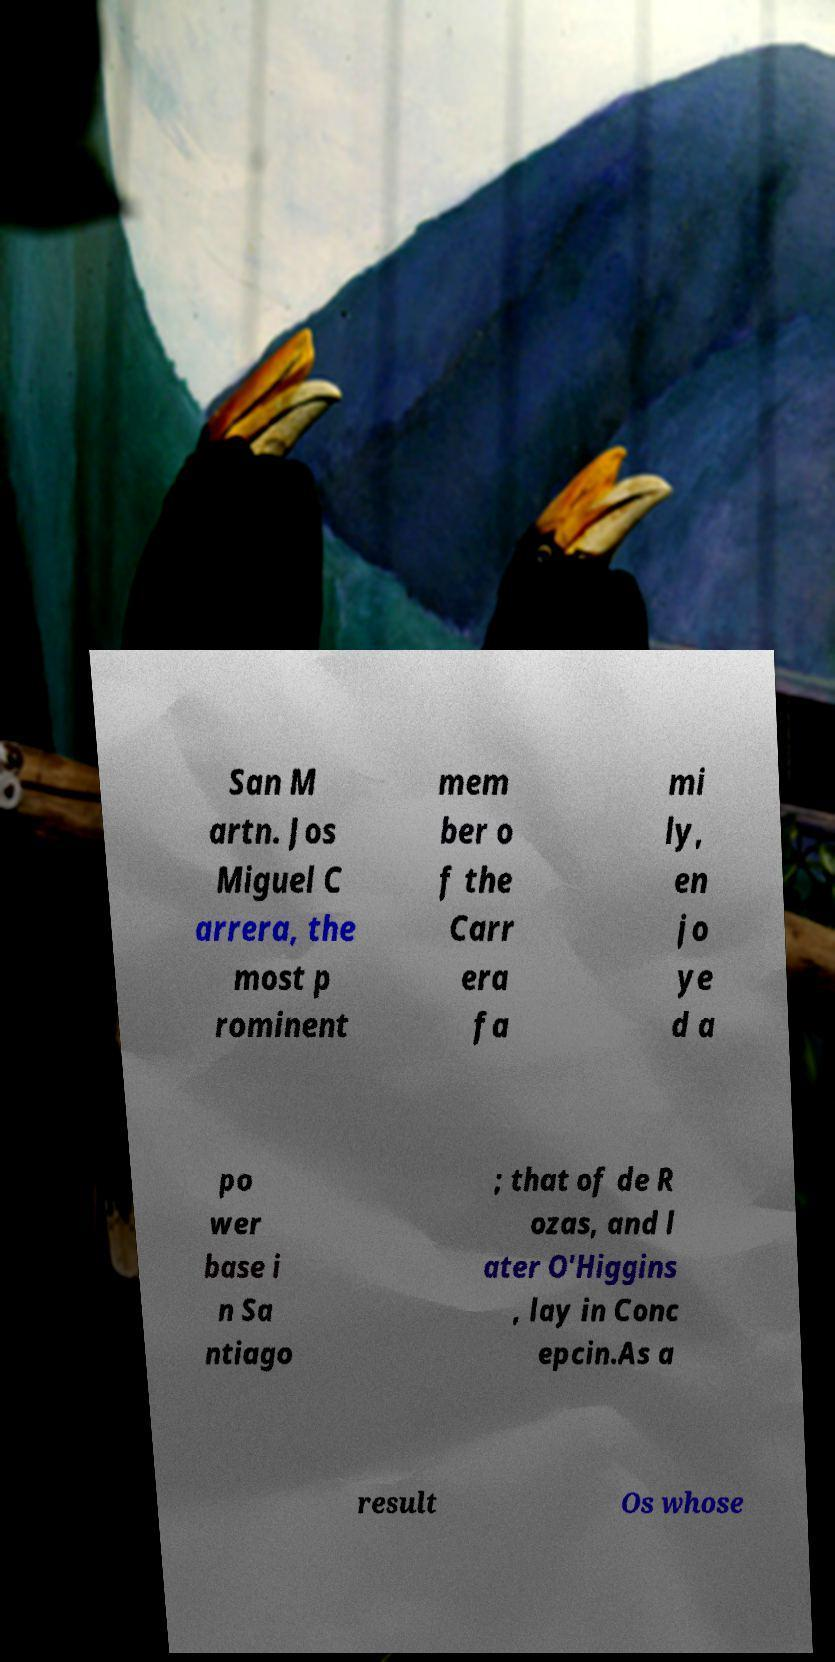Please identify and transcribe the text found in this image. San M artn. Jos Miguel C arrera, the most p rominent mem ber o f the Carr era fa mi ly, en jo ye d a po wer base i n Sa ntiago ; that of de R ozas, and l ater O'Higgins , lay in Conc epcin.As a result Os whose 